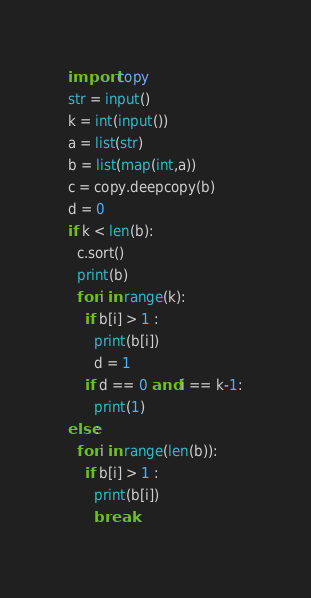Convert code to text. <code><loc_0><loc_0><loc_500><loc_500><_Python_>import copy
str = input()
k = int(input())
a = list(str)
b = list(map(int,a))
c = copy.deepcopy(b)
d = 0
if k < len(b):
  c.sort()
  print(b)
  for i in range(k):
    if b[i] > 1 :
      print(b[i])
      d = 1
    if d == 0 and i == k-1:
      print(1)
else:
  for i in range(len(b)):
    if b[i] > 1 :
      print(b[i])
      break</code> 